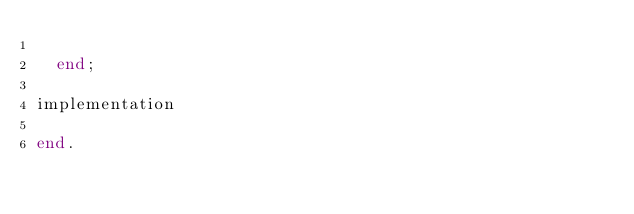Convert code to text. <code><loc_0><loc_0><loc_500><loc_500><_Pascal_>
  end;

implementation

end.
</code> 